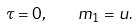<formula> <loc_0><loc_0><loc_500><loc_500>\tau = 0 , \quad m _ { 1 } = u .</formula> 